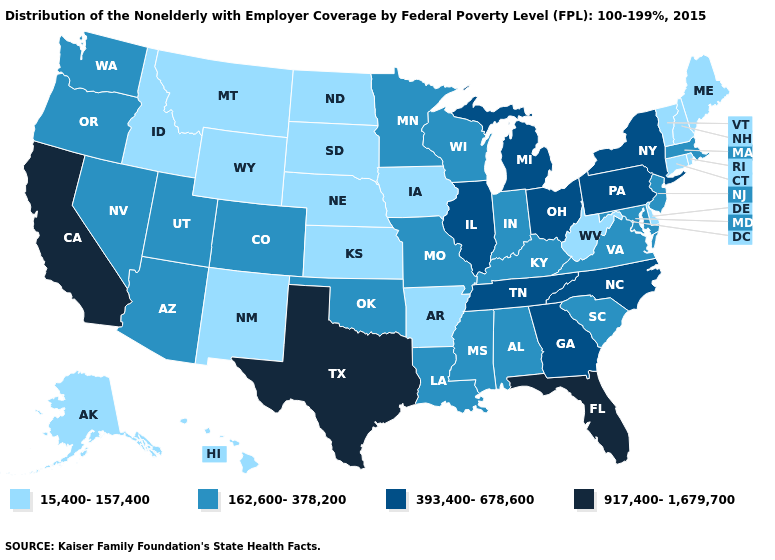What is the value of Kentucky?
Short answer required. 162,600-378,200. Does Wisconsin have the highest value in the USA?
Answer briefly. No. Name the states that have a value in the range 393,400-678,600?
Quick response, please. Georgia, Illinois, Michigan, New York, North Carolina, Ohio, Pennsylvania, Tennessee. What is the value of Nevada?
Quick response, please. 162,600-378,200. What is the highest value in states that border California?
Short answer required. 162,600-378,200. Which states have the lowest value in the Northeast?
Quick response, please. Connecticut, Maine, New Hampshire, Rhode Island, Vermont. Does New Hampshire have the same value as Kansas?
Short answer required. Yes. Does the map have missing data?
Short answer required. No. Name the states that have a value in the range 917,400-1,679,700?
Short answer required. California, Florida, Texas. Does North Carolina have the same value as Pennsylvania?
Answer briefly. Yes. What is the highest value in the South ?
Be succinct. 917,400-1,679,700. Does Massachusetts have the lowest value in the USA?
Answer briefly. No. What is the value of Colorado?
Quick response, please. 162,600-378,200. Name the states that have a value in the range 393,400-678,600?
Answer briefly. Georgia, Illinois, Michigan, New York, North Carolina, Ohio, Pennsylvania, Tennessee. 